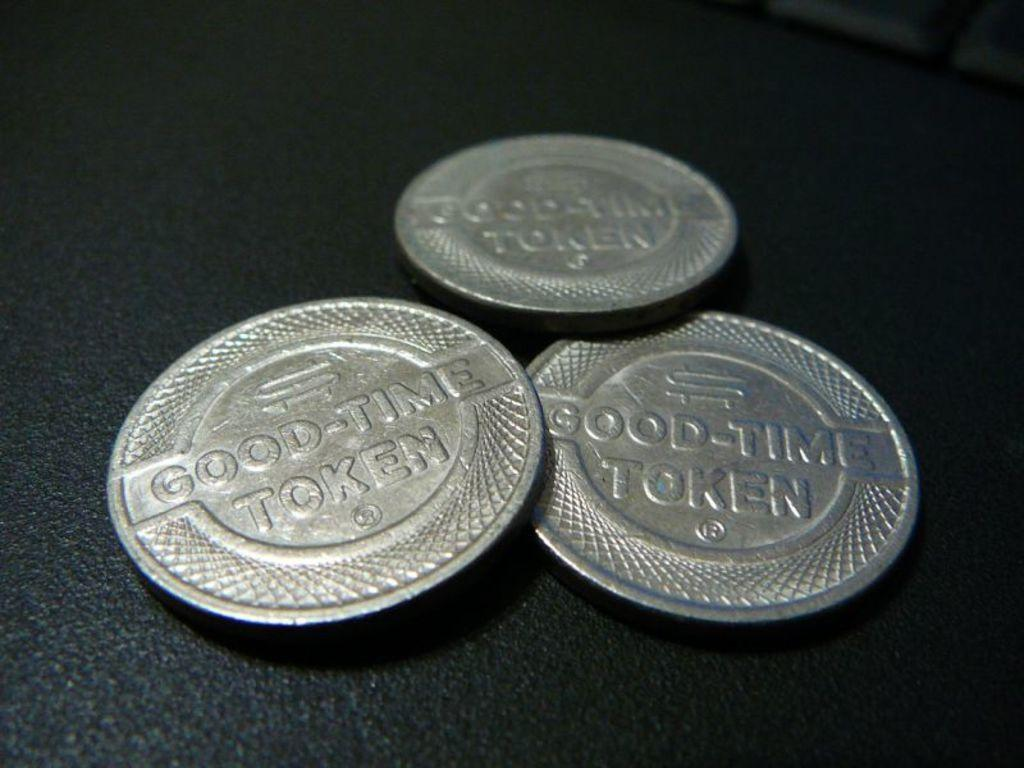<image>
Offer a succinct explanation of the picture presented. A table with three silver coins that say Good-Time Token. 